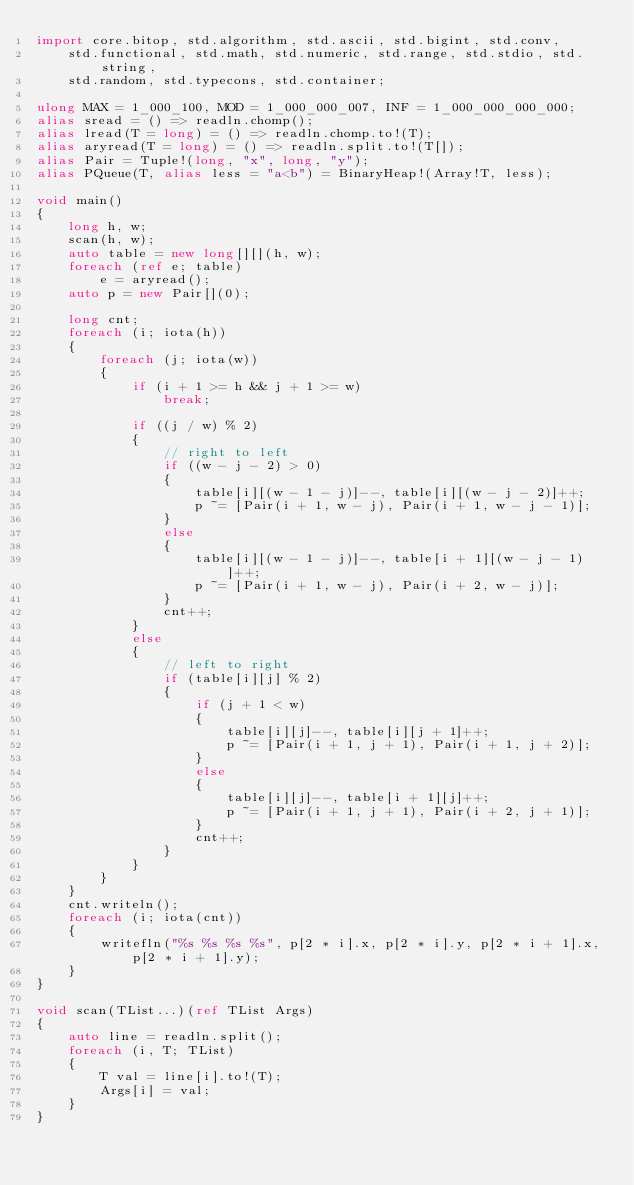<code> <loc_0><loc_0><loc_500><loc_500><_D_>import core.bitop, std.algorithm, std.ascii, std.bigint, std.conv,
    std.functional, std.math, std.numeric, std.range, std.stdio, std.string,
    std.random, std.typecons, std.container;

ulong MAX = 1_000_100, MOD = 1_000_000_007, INF = 1_000_000_000_000;
alias sread = () => readln.chomp();
alias lread(T = long) = () => readln.chomp.to!(T);
alias aryread(T = long) = () => readln.split.to!(T[]);
alias Pair = Tuple!(long, "x", long, "y");
alias PQueue(T, alias less = "a<b") = BinaryHeap!(Array!T, less);

void main()
{
    long h, w;
    scan(h, w);
    auto table = new long[][](h, w);
    foreach (ref e; table)
        e = aryread();
    auto p = new Pair[](0);

    long cnt;
    foreach (i; iota(h))
    {
        foreach (j; iota(w))
        {
            if (i + 1 >= h && j + 1 >= w)
                break;

            if ((j / w) % 2)
            {
                // right to left
                if ((w - j - 2) > 0)
                {
                    table[i][(w - 1 - j)]--, table[i][(w - j - 2)]++;
                    p ~= [Pair(i + 1, w - j), Pair(i + 1, w - j - 1)];
                }
                else
                {
                    table[i][(w - 1 - j)]--, table[i + 1][(w - j - 1)]++;
                    p ~= [Pair(i + 1, w - j), Pair(i + 2, w - j)];
                }
                cnt++;
            }
            else
            {
                // left to right
                if (table[i][j] % 2)
                {
                    if (j + 1 < w)
                    {
                        table[i][j]--, table[i][j + 1]++;
                        p ~= [Pair(i + 1, j + 1), Pair(i + 1, j + 2)];
                    }
                    else
                    {
                        table[i][j]--, table[i + 1][j]++;
                        p ~= [Pair(i + 1, j + 1), Pair(i + 2, j + 1)];
                    }
                    cnt++;
                }
            }
        }
    }
    cnt.writeln();
    foreach (i; iota(cnt))
    {
        writefln("%s %s %s %s", p[2 * i].x, p[2 * i].y, p[2 * i + 1].x, p[2 * i + 1].y);
    }
}

void scan(TList...)(ref TList Args)
{
    auto line = readln.split();
    foreach (i, T; TList)
    {
        T val = line[i].to!(T);
        Args[i] = val;
    }
}
</code> 